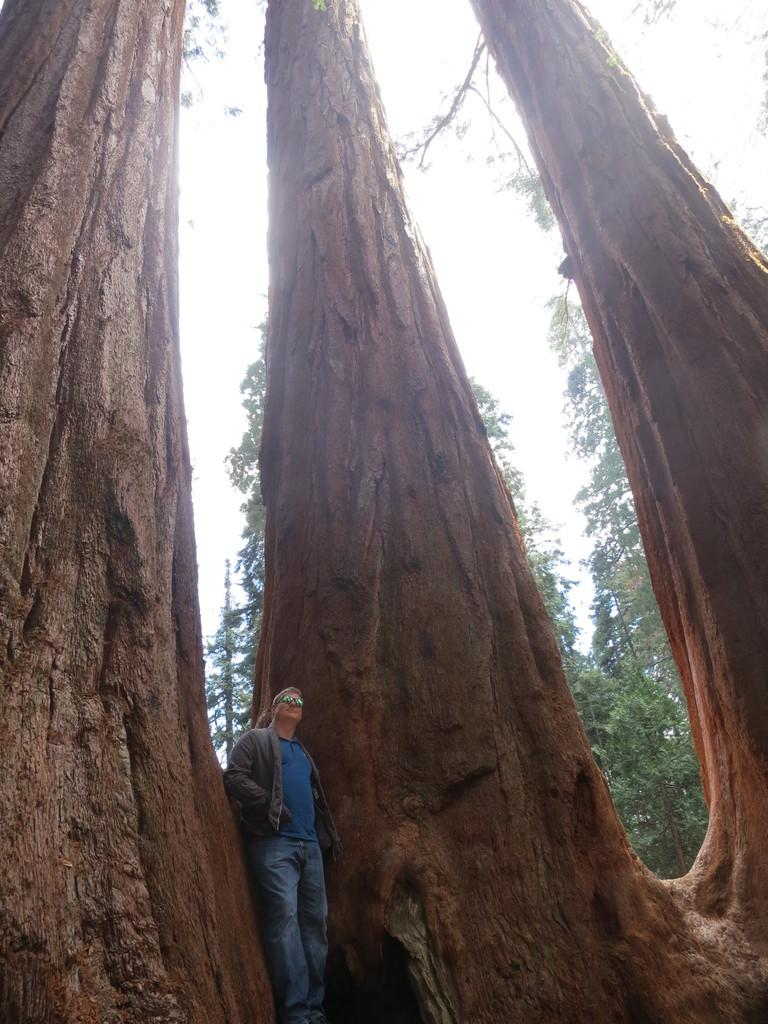What is the main subject in the middle of the image? There is a man standing in the middle of the image. What can be seen behind the man? There are trees behind the man. What is visible at the top of the image? The sky is visible at the top of the image. What type of pig can be seen hiding behind the curtain in the image? There is no pig or curtain present in the image. 